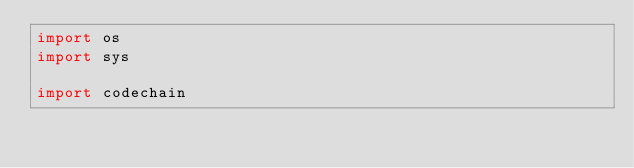<code> <loc_0><loc_0><loc_500><loc_500><_Python_>import os
import sys

import codechain
</code> 